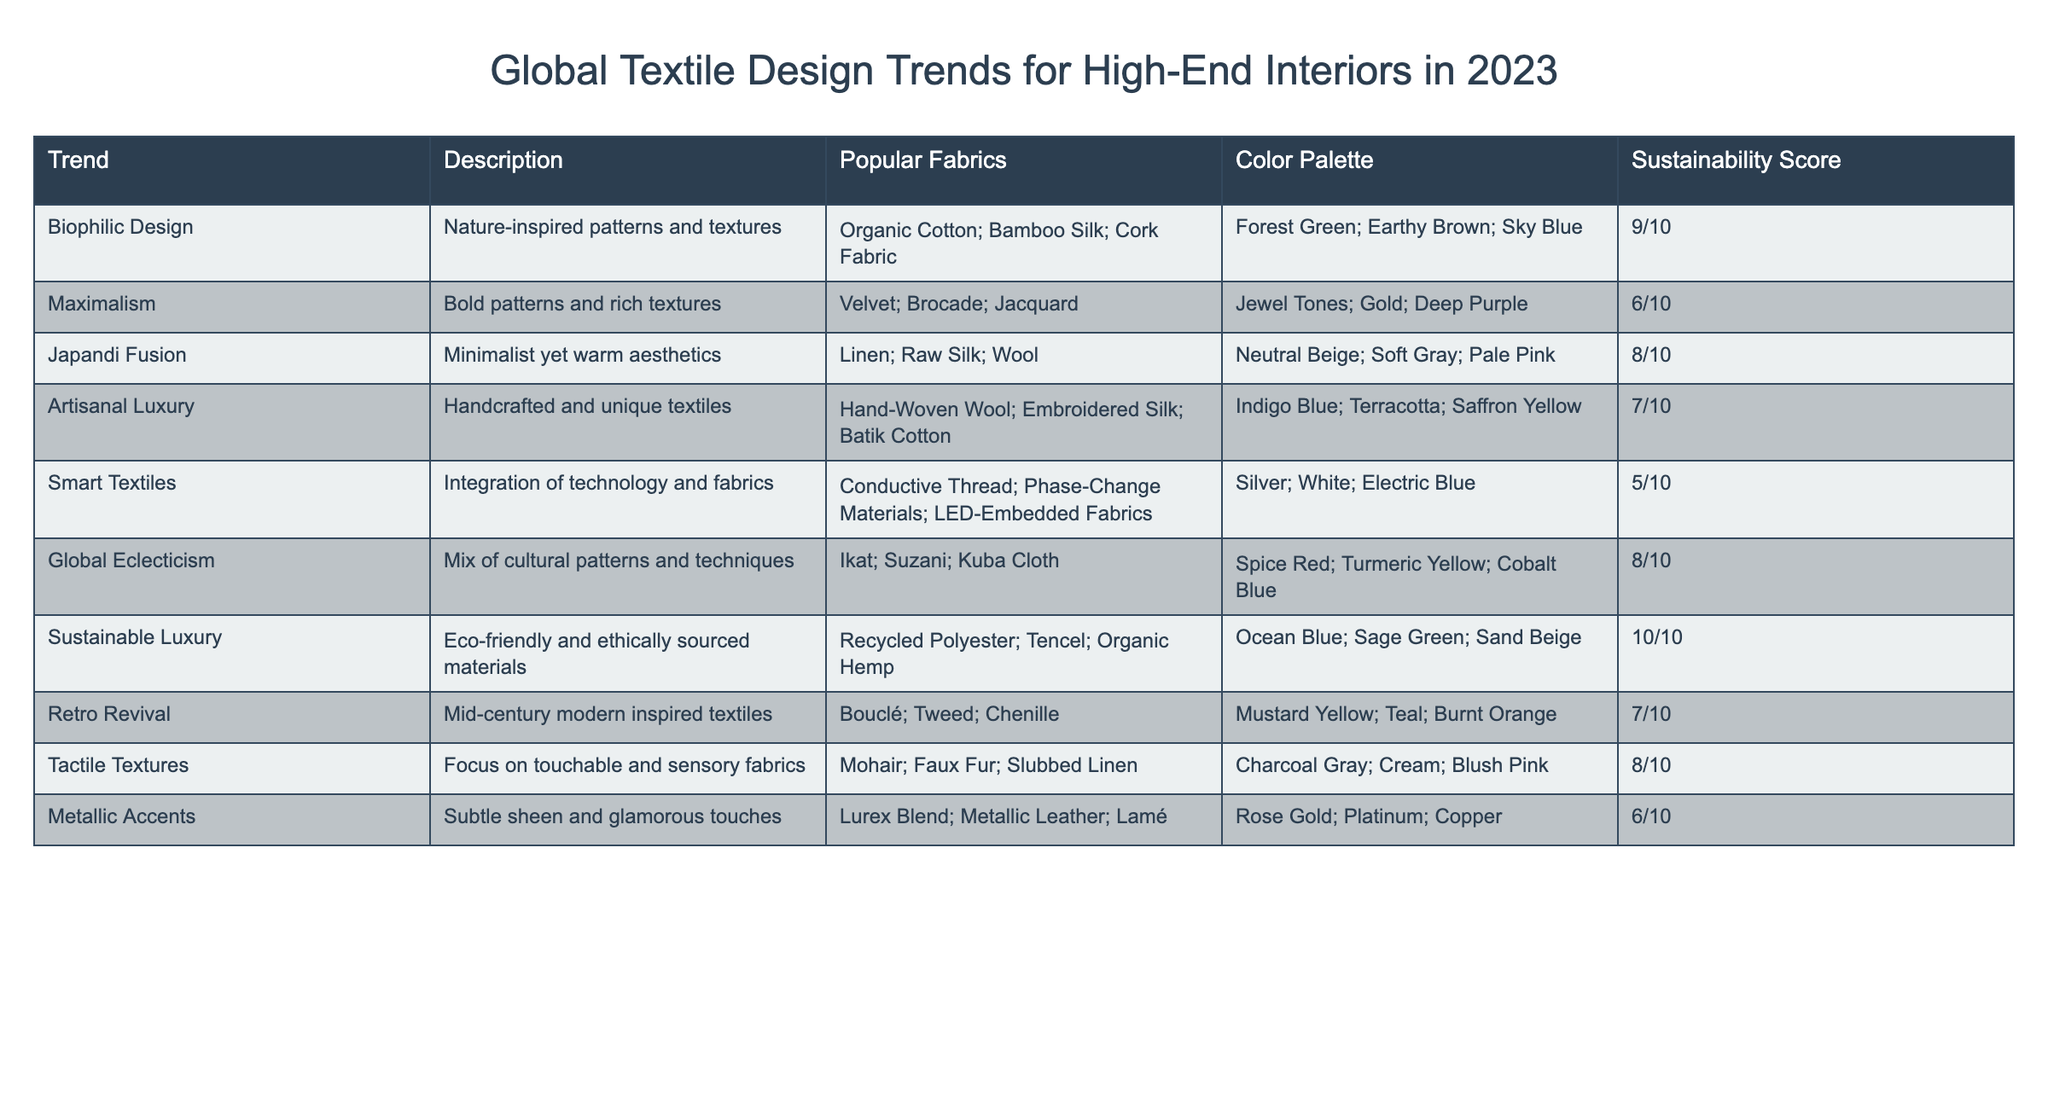What is the sustainability score for Sustainable Luxury? The table lists a sustainability score for each trend. For Sustainable Luxury, it shows a score of 10/10.
Answer: 10/10 Which trend has the highest sustainability score? By examining the sustainability scores in the table, Sustainable Luxury has the highest score of 10/10.
Answer: Sustainable Luxury What are the popular fabrics associated with Maximalism? The table lists the popular fabrics for each trend. Maximalism includes Velvet, Brocade, and Jacquard.
Answer: Velvet, Brocade, Jacquard Is the color palette for Tactile Textures more neutral or vibrant? The color palette for Tactile Textures includes Charcoal Gray, Cream, and Blush Pink, which are more neutral colors.
Answer: More neutral What is the average sustainability score of trends with a score of 8 or higher? The sustainability scores of the applicable trends are: 9 (Biophilic Design), 8 (Japandi Fusion), 8 (Global Eclecticism), and 8 (Tactile Textures). The average is (9 + 8 + 8 + 8) / 4 = 8.25.
Answer: 8.25 Which trend features a mix of cultural patterns? The table indicates that Global Eclecticism is the trend that features a mix of cultural patterns and techniques, such as Ikat, Suzani, and Kuba Cloth.
Answer: Global Eclecticism Are Smart Textiles considered to be highly sustainable based on their score? Smart Textiles have a sustainability score of 5/10, indicating that they are not considered highly sustainable.
Answer: No How many trends are associated with a score of 6 or lower? The trends with sustainability scores of 6 or lower are Maximalism (6), Smart Textiles (5), and Metallic Accents (6). There are 3 trends in total.
Answer: 3 Which trend uses eco-friendly and ethically sourced materials? The description for the Sustainable Luxury trend specifies that it uses eco-friendly and ethically sourced materials.
Answer: Sustainable Luxury What color palette is associated with Japandi Fusion? According to the table, the color palette for Japandi Fusion includes Neutral Beige, Soft Gray, and Pale Pink.
Answer: Neutral Beige, Soft Gray, Pale Pink 